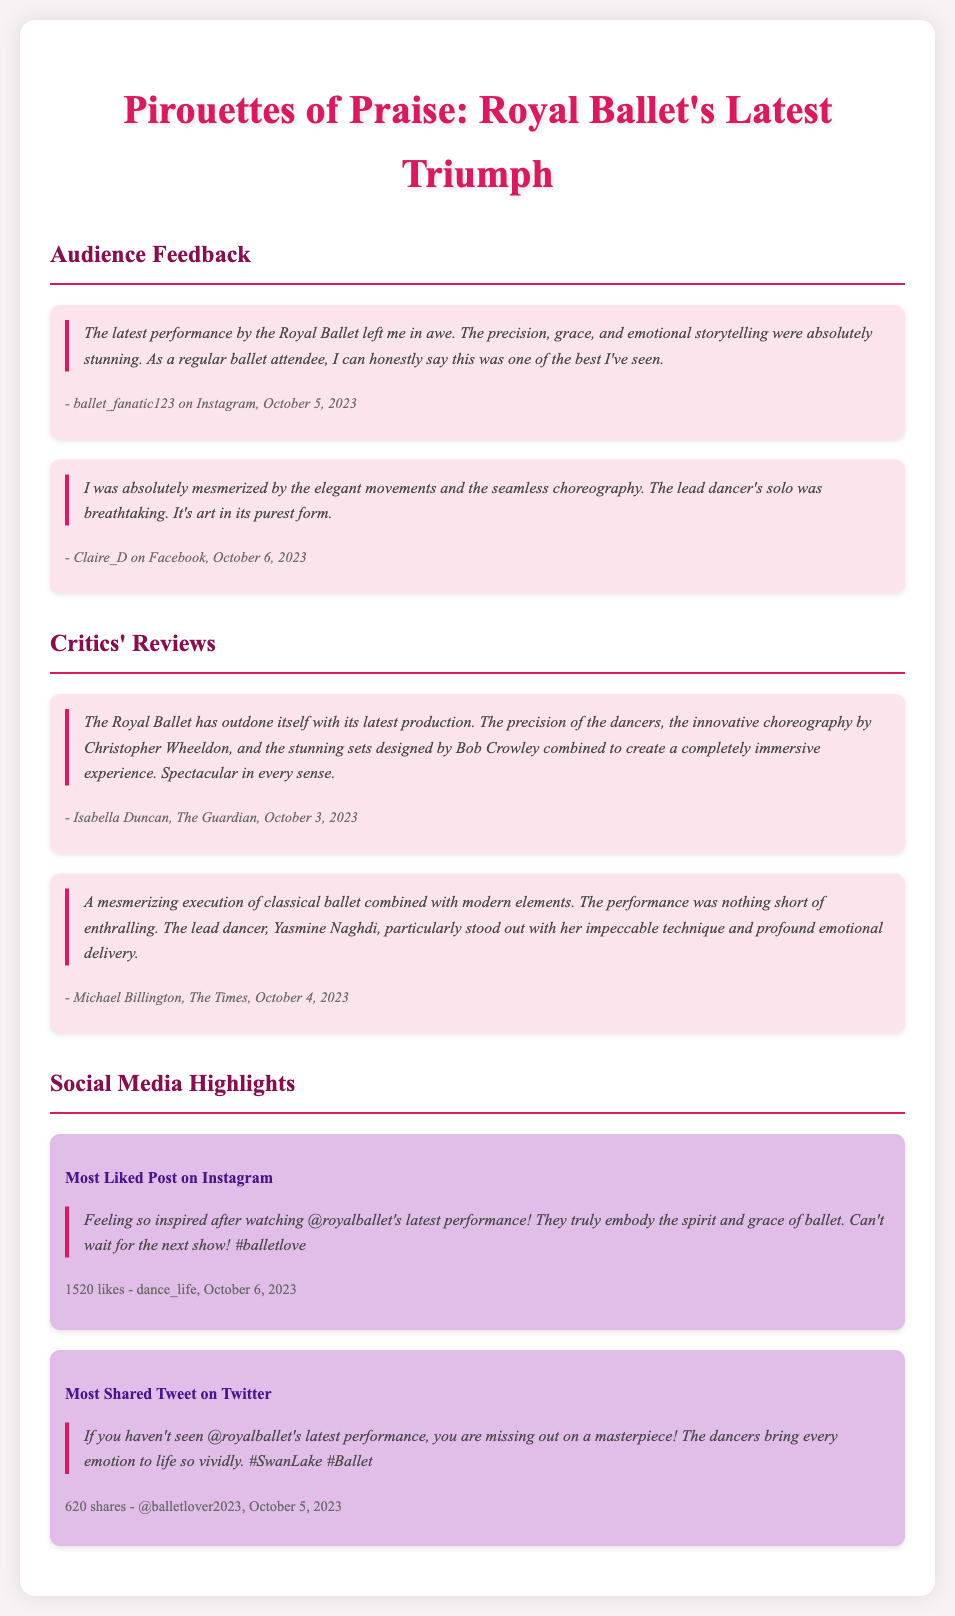What was the performance's title? The title mentioned in the document is "Pirouettes of Praise."
Answer: Pirouettes of Praise Who wrote the review for The Guardian? The review for The Guardian is credited to Isabella Duncan.
Answer: Isabella Duncan What date did ballet_fanatic123 post their review? The date of ballet_fanatic123's post is provided as October 5, 2023.
Answer: October 5, 2023 What was the most liked post's number of likes? The social media highlight indicates that the most liked post received 1520 likes.
Answer: 1520 likes Which lead dancer is specifically mentioned in the critics' reviews? The lead dancer highlighted in the critics' reviews is Yasmine Naghdi.
Answer: Yasmine Naghdi How many shares did the most shared tweet receive? The most shared tweet on Twitter received 620 shares.
Answer: 620 shares What type of choreography is mentioned as part of the latest performance? The choreography of the performance is described as innovative, blending classical and modern elements.
Answer: Innovative choreography How did Claire_D describe the lead dancer's solo? Claire_D described the lead dancer's solo as breathtaking.
Answer: Breathtaking What is the hashtag used in the most liked Instagram post? The hashtag used in the most liked Instagram post is #balletlove.
Answer: #balletlove 